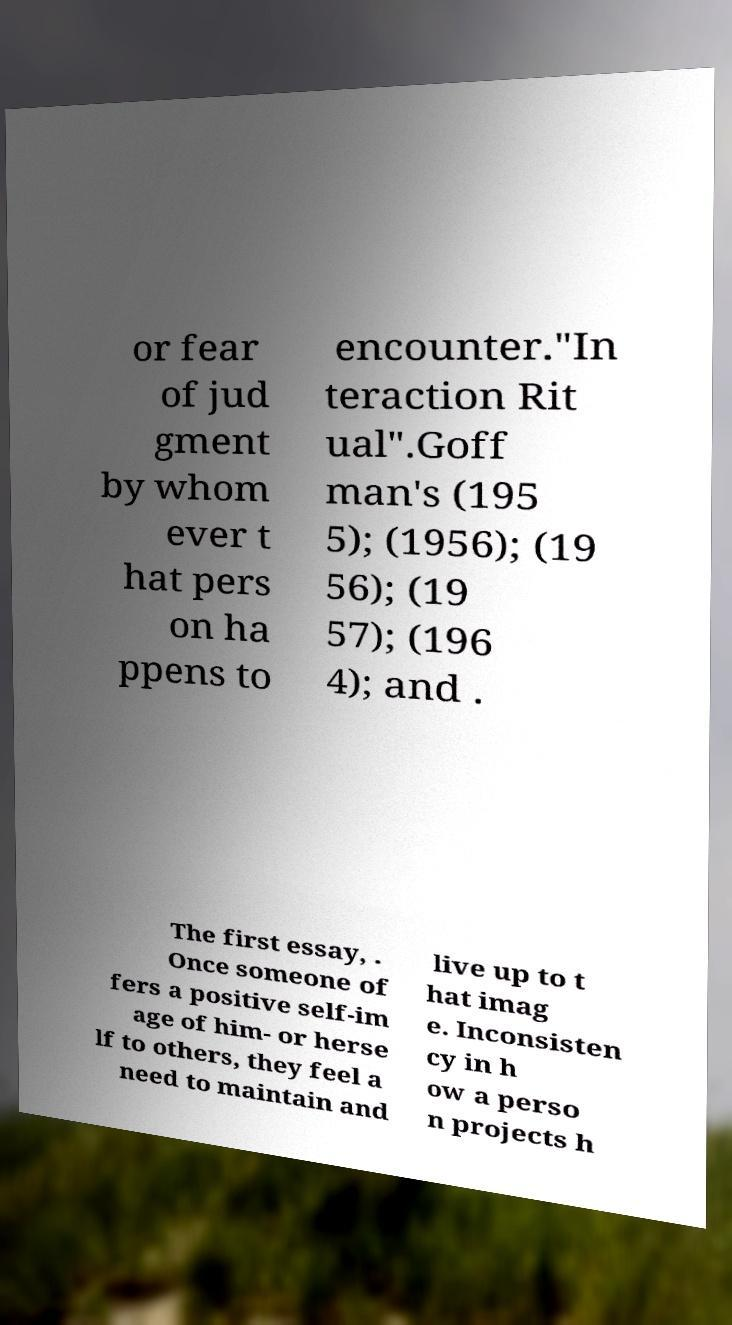Could you extract and type out the text from this image? or fear of jud gment by whom ever t hat pers on ha ppens to encounter."In teraction Rit ual".Goff man's (195 5); (1956); (19 56); (19 57); (196 4); and . The first essay, . Once someone of fers a positive self-im age of him- or herse lf to others, they feel a need to maintain and live up to t hat imag e. Inconsisten cy in h ow a perso n projects h 